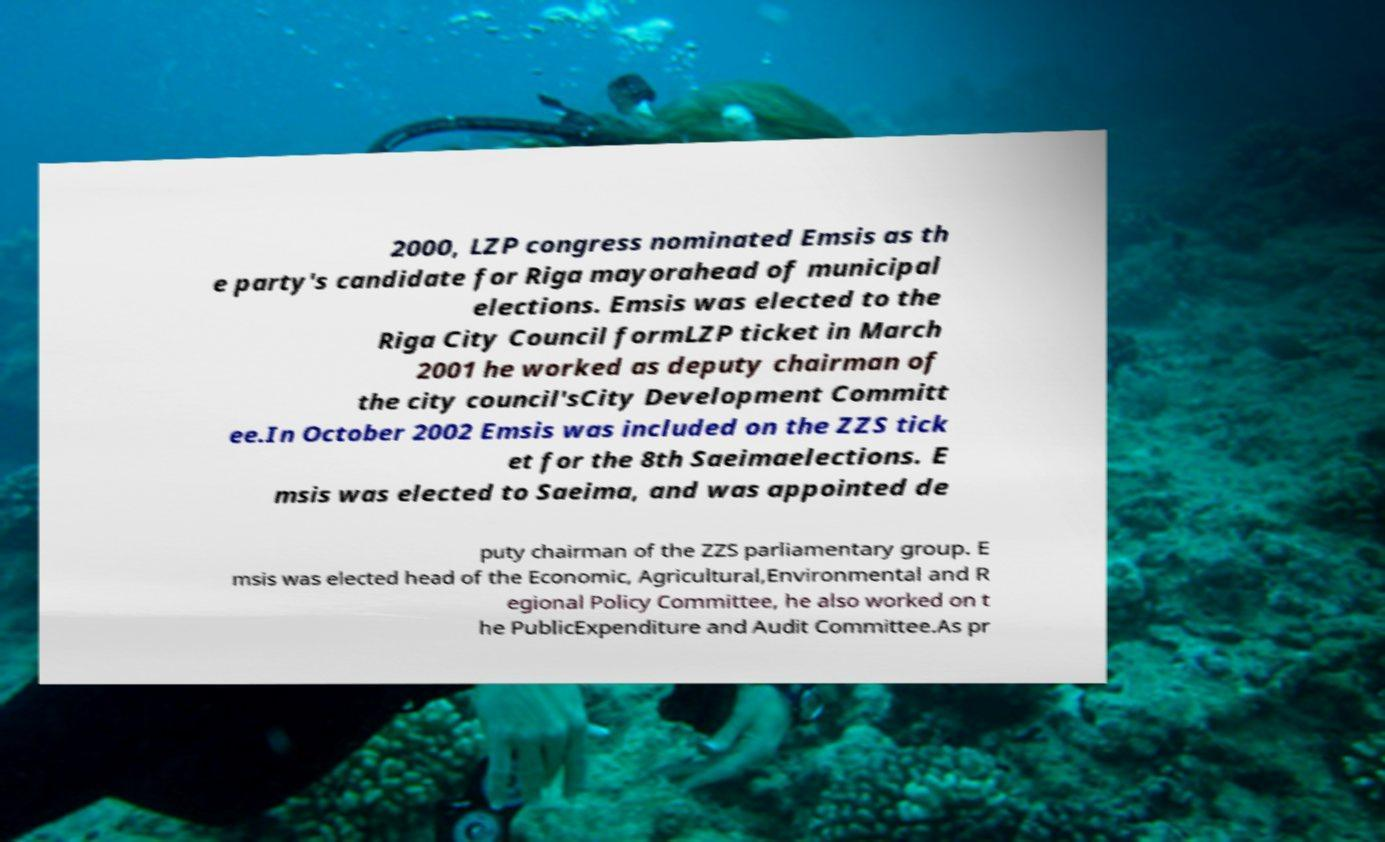Could you assist in decoding the text presented in this image and type it out clearly? 2000, LZP congress nominated Emsis as th e party's candidate for Riga mayorahead of municipal elections. Emsis was elected to the Riga City Council formLZP ticket in March 2001 he worked as deputy chairman of the city council'sCity Development Committ ee.In October 2002 Emsis was included on the ZZS tick et for the 8th Saeimaelections. E msis was elected to Saeima, and was appointed de puty chairman of the ZZS parliamentary group. E msis was elected head of the Economic, Agricultural,Environmental and R egional Policy Committee, he also worked on t he PublicExpenditure and Audit Committee.As pr 